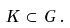<formula> <loc_0><loc_0><loc_500><loc_500>K \, \subset \, G \, .</formula> 